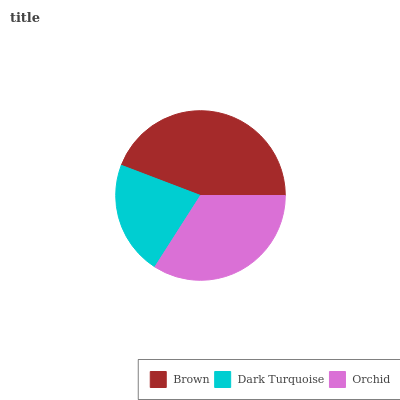Is Dark Turquoise the minimum?
Answer yes or no. Yes. Is Brown the maximum?
Answer yes or no. Yes. Is Orchid the minimum?
Answer yes or no. No. Is Orchid the maximum?
Answer yes or no. No. Is Orchid greater than Dark Turquoise?
Answer yes or no. Yes. Is Dark Turquoise less than Orchid?
Answer yes or no. Yes. Is Dark Turquoise greater than Orchid?
Answer yes or no. No. Is Orchid less than Dark Turquoise?
Answer yes or no. No. Is Orchid the high median?
Answer yes or no. Yes. Is Orchid the low median?
Answer yes or no. Yes. Is Dark Turquoise the high median?
Answer yes or no. No. Is Dark Turquoise the low median?
Answer yes or no. No. 